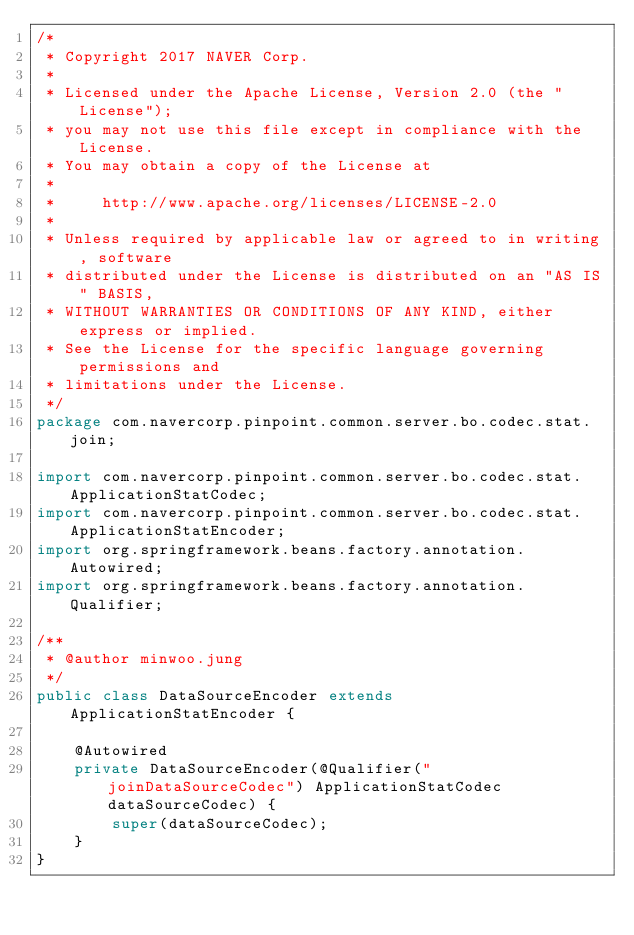<code> <loc_0><loc_0><loc_500><loc_500><_Java_>/*
 * Copyright 2017 NAVER Corp.
 *
 * Licensed under the Apache License, Version 2.0 (the "License");
 * you may not use this file except in compliance with the License.
 * You may obtain a copy of the License at
 *
 *     http://www.apache.org/licenses/LICENSE-2.0
 *
 * Unless required by applicable law or agreed to in writing, software
 * distributed under the License is distributed on an "AS IS" BASIS,
 * WITHOUT WARRANTIES OR CONDITIONS OF ANY KIND, either express or implied.
 * See the License for the specific language governing permissions and
 * limitations under the License.
 */
package com.navercorp.pinpoint.common.server.bo.codec.stat.join;

import com.navercorp.pinpoint.common.server.bo.codec.stat.ApplicationStatCodec;
import com.navercorp.pinpoint.common.server.bo.codec.stat.ApplicationStatEncoder;
import org.springframework.beans.factory.annotation.Autowired;
import org.springframework.beans.factory.annotation.Qualifier;

/**
 * @author minwoo.jung
 */
public class DataSourceEncoder extends ApplicationStatEncoder {

    @Autowired
    private DataSourceEncoder(@Qualifier("joinDataSourceCodec") ApplicationStatCodec dataSourceCodec) {
        super(dataSourceCodec);
    }
}
</code> 